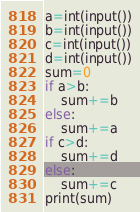Convert code to text. <code><loc_0><loc_0><loc_500><loc_500><_Python_>a=int(input())
b=int(input())
c=int(input())
d=int(input())
sum=0
if a>b:
    sum+=b
else:
    sum+=a
if c>d:
    sum+=d
else:
    sum+=c
print(sum)</code> 